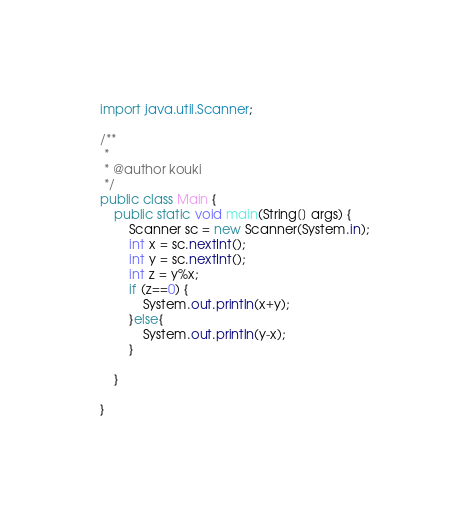<code> <loc_0><loc_0><loc_500><loc_500><_Java_>import java.util.Scanner;

/**
 *
 * @author kouki
 */
public class Main {
    public static void main(String[] args) {
        Scanner sc = new Scanner(System.in);
        int x = sc.nextInt();
        int y = sc.nextInt();
        int z = y%x;
        if (z==0) {
            System.out.println(x+y);
        }else{
            System.out.println(y-x);
        }
        
    }
    
}</code> 